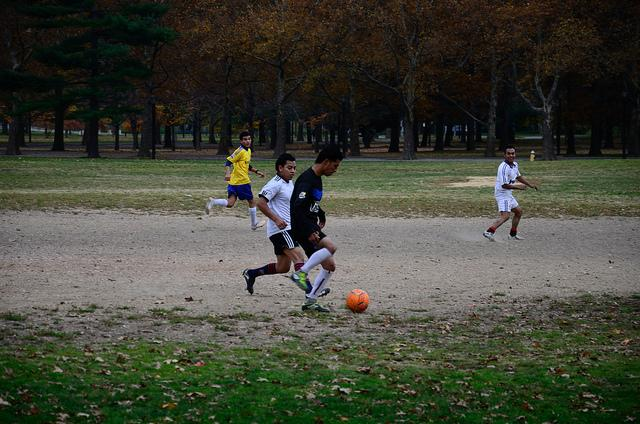What are the boys doing with the orange ball? soccer 